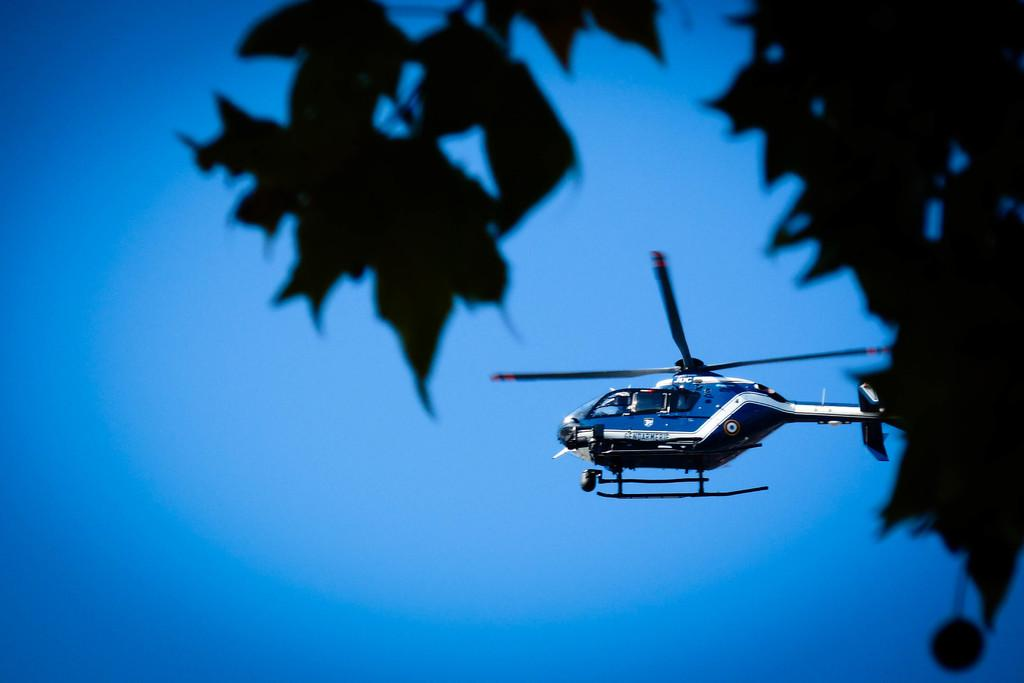What can be seen in the background of the image? The sky is visible in the background of the image. What is flying in the air in the image? There is a helicopter in the air in the image. What type of vegetation is on the right side of the image? There are leaves on the right side of the image. What type of quiver is visible on the helicopter in the image? There is no quiver present on the helicopter in the image. How many tents can be seen in the image? There are no tents present in the image. 